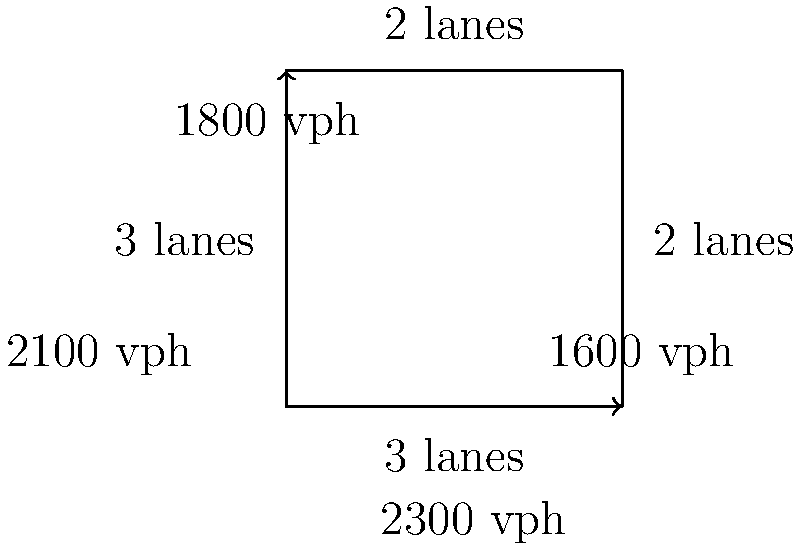Given the schematic layout of a highway intersection shown above, with the number of lanes and traffic flow values (in vehicles per hour) for each approach, estimate the total traffic flow capacity of this intersection. Assume each lane can handle a maximum of 900 vehicles per hour. To estimate the total traffic flow capacity of this intersection, we need to follow these steps:

1. Identify the number of lanes for each approach:
   - Northbound: 2 lanes
   - Eastbound: 2 lanes
   - Southbound: 3 lanes
   - Westbound: 3 lanes

2. Calculate the maximum capacity for each approach:
   - Northbound: $2 \times 900 = 1800$ vph
   - Eastbound: $2 \times 900 = 1800$ vph
   - Southbound: $3 \times 900 = 2700$ vph
   - Westbound: $3 \times 900 = 2700$ vph

3. Compare the given traffic flow values with the maximum capacity for each approach:
   - Northbound: 1800 vph (at capacity)
   - Eastbound: 1600 vph (below capacity)
   - Southbound: 2300 vph (below capacity)
   - Westbound: 2100 vph (below capacity)

4. Sum up the traffic flow values for all approaches:
   $1800 + 1600 + 2300 + 2100 = 7800$ vph

Therefore, the estimated total traffic flow capacity of this intersection is 7800 vehicles per hour.
Answer: 7800 vehicles per hour 